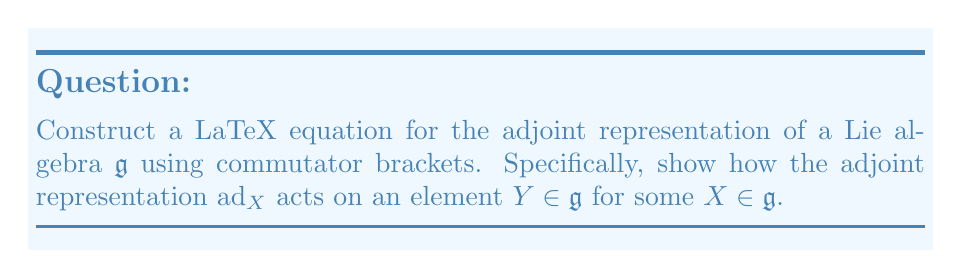Help me with this question. To construct the LaTeX equation for the adjoint representation of a Lie algebra using commutator brackets, we follow these steps:

1) The adjoint representation of a Lie algebra $\mathfrak{g}$ is defined as a linear map $\text{ad}: \mathfrak{g} \to \text{End}(\mathfrak{g})$, where $\text{End}(\mathfrak{g})$ is the set of linear transformations from $\mathfrak{g}$ to itself.

2) For any element $X \in \mathfrak{g}$, the adjoint representation $\text{ad}_X$ is defined as:

   $$\text{ad}_X: \mathfrak{g} \to \mathfrak{g}$$

3) The action of $\text{ad}_X$ on any element $Y \in \mathfrak{g}$ is given by the commutator bracket:

   $$\text{ad}_X(Y) = [X,Y]$$

4) In LaTeX, we can represent this equation as:

   $$\text{ad}_X(Y) = [X,Y]$$

5) To emphasize that this is a linear map, we can also write it as:

   $$\text{ad}_X: Y \mapsto [X,Y]$$

Therefore, the complete LaTeX equation for the adjoint representation of a Lie algebra using commutator brackets is:

$$\text{ad}_X: \mathfrak{g} \to \mathfrak{g}, \quad Y \mapsto [X,Y]$$
Answer: $$\text{ad}_X: \mathfrak{g} \to \mathfrak{g}, \quad Y \mapsto [X,Y]$$ 